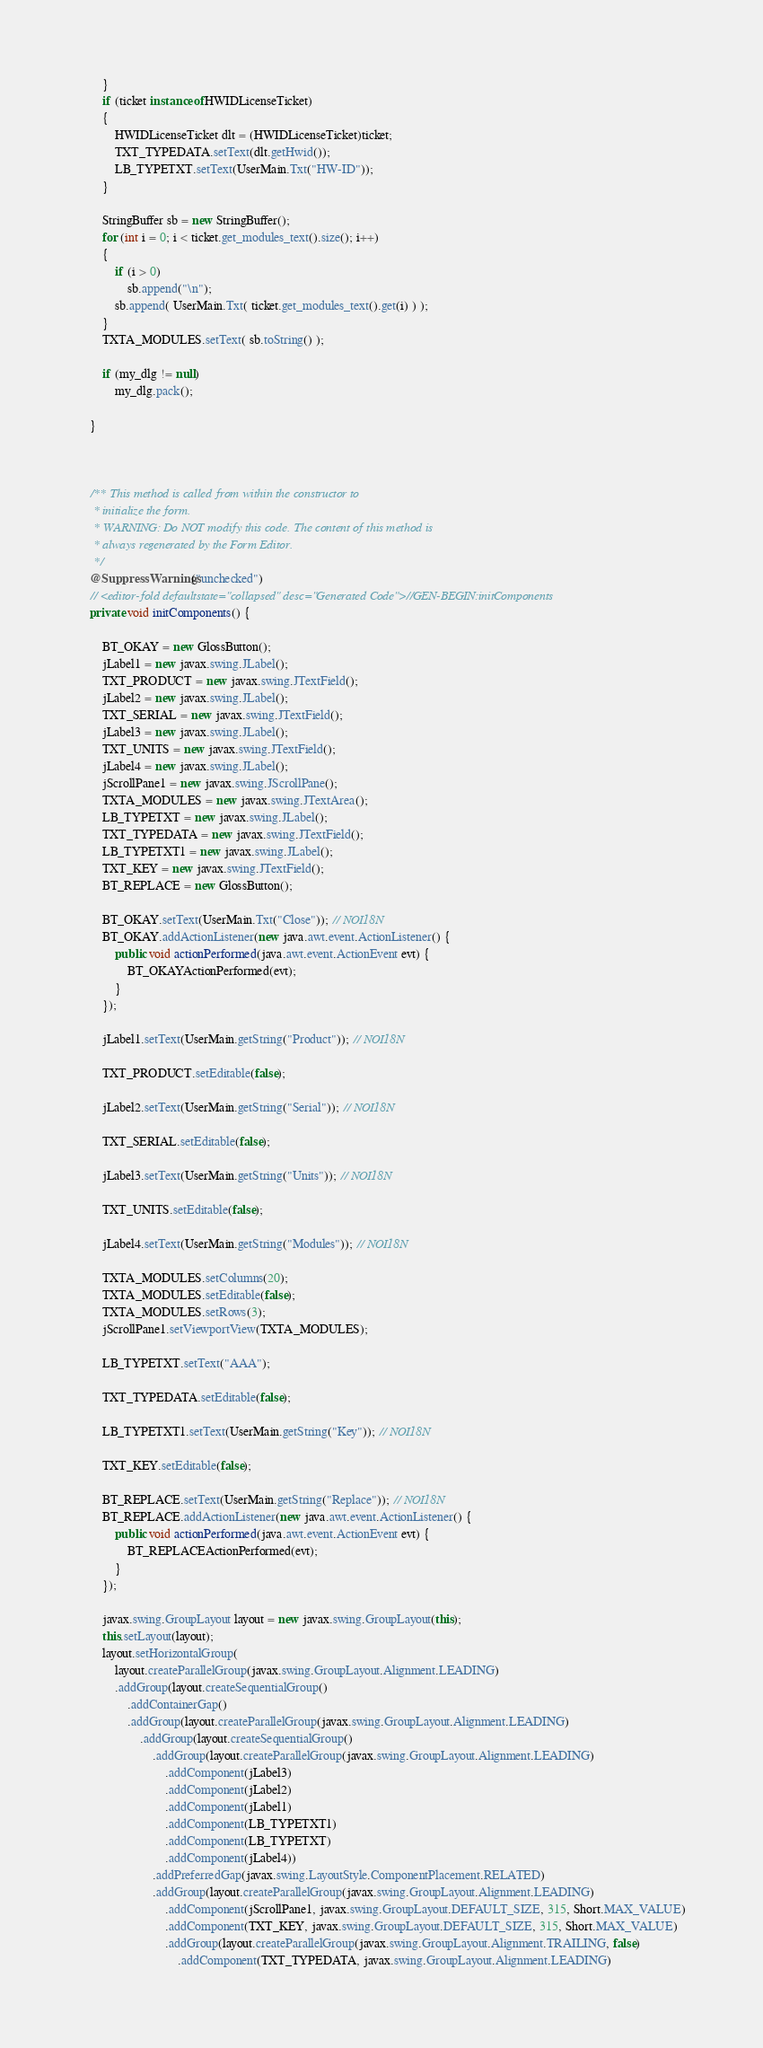Convert code to text. <code><loc_0><loc_0><loc_500><loc_500><_Java_>        }
        if (ticket instanceof HWIDLicenseTicket)
        {
            HWIDLicenseTicket dlt = (HWIDLicenseTicket)ticket;
            TXT_TYPEDATA.setText(dlt.getHwid());
            LB_TYPETXT.setText(UserMain.Txt("HW-ID"));
        }
        
        StringBuffer sb = new StringBuffer();
        for (int i = 0; i < ticket.get_modules_text().size(); i++)
        {
            if (i > 0)
                sb.append("\n");
            sb.append( UserMain.Txt( ticket.get_modules_text().get(i) ) );
        }
        TXTA_MODULES.setText( sb.toString() );

        if (my_dlg != null)
            my_dlg.pack();
        
    }



    /** This method is called from within the constructor to
     * initialize the form.
     * WARNING: Do NOT modify this code. The content of this method is
     * always regenerated by the Form Editor.
     */
    @SuppressWarnings("unchecked")
    // <editor-fold defaultstate="collapsed" desc="Generated Code">//GEN-BEGIN:initComponents
    private void initComponents() {

        BT_OKAY = new GlossButton();
        jLabel1 = new javax.swing.JLabel();
        TXT_PRODUCT = new javax.swing.JTextField();
        jLabel2 = new javax.swing.JLabel();
        TXT_SERIAL = new javax.swing.JTextField();
        jLabel3 = new javax.swing.JLabel();
        TXT_UNITS = new javax.swing.JTextField();
        jLabel4 = new javax.swing.JLabel();
        jScrollPane1 = new javax.swing.JScrollPane();
        TXTA_MODULES = new javax.swing.JTextArea();
        LB_TYPETXT = new javax.swing.JLabel();
        TXT_TYPEDATA = new javax.swing.JTextField();
        LB_TYPETXT1 = new javax.swing.JLabel();
        TXT_KEY = new javax.swing.JTextField();
        BT_REPLACE = new GlossButton();

        BT_OKAY.setText(UserMain.Txt("Close")); // NOI18N
        BT_OKAY.addActionListener(new java.awt.event.ActionListener() {
            public void actionPerformed(java.awt.event.ActionEvent evt) {
                BT_OKAYActionPerformed(evt);
            }
        });

        jLabel1.setText(UserMain.getString("Product")); // NOI18N

        TXT_PRODUCT.setEditable(false);

        jLabel2.setText(UserMain.getString("Serial")); // NOI18N

        TXT_SERIAL.setEditable(false);

        jLabel3.setText(UserMain.getString("Units")); // NOI18N

        TXT_UNITS.setEditable(false);

        jLabel4.setText(UserMain.getString("Modules")); // NOI18N

        TXTA_MODULES.setColumns(20);
        TXTA_MODULES.setEditable(false);
        TXTA_MODULES.setRows(3);
        jScrollPane1.setViewportView(TXTA_MODULES);

        LB_TYPETXT.setText("AAA");

        TXT_TYPEDATA.setEditable(false);

        LB_TYPETXT1.setText(UserMain.getString("Key")); // NOI18N

        TXT_KEY.setEditable(false);

        BT_REPLACE.setText(UserMain.getString("Replace")); // NOI18N
        BT_REPLACE.addActionListener(new java.awt.event.ActionListener() {
            public void actionPerformed(java.awt.event.ActionEvent evt) {
                BT_REPLACEActionPerformed(evt);
            }
        });

        javax.swing.GroupLayout layout = new javax.swing.GroupLayout(this);
        this.setLayout(layout);
        layout.setHorizontalGroup(
            layout.createParallelGroup(javax.swing.GroupLayout.Alignment.LEADING)
            .addGroup(layout.createSequentialGroup()
                .addContainerGap()
                .addGroup(layout.createParallelGroup(javax.swing.GroupLayout.Alignment.LEADING)
                    .addGroup(layout.createSequentialGroup()
                        .addGroup(layout.createParallelGroup(javax.swing.GroupLayout.Alignment.LEADING)
                            .addComponent(jLabel3)
                            .addComponent(jLabel2)
                            .addComponent(jLabel1)
                            .addComponent(LB_TYPETXT1)
                            .addComponent(LB_TYPETXT)
                            .addComponent(jLabel4))
                        .addPreferredGap(javax.swing.LayoutStyle.ComponentPlacement.RELATED)
                        .addGroup(layout.createParallelGroup(javax.swing.GroupLayout.Alignment.LEADING)
                            .addComponent(jScrollPane1, javax.swing.GroupLayout.DEFAULT_SIZE, 315, Short.MAX_VALUE)
                            .addComponent(TXT_KEY, javax.swing.GroupLayout.DEFAULT_SIZE, 315, Short.MAX_VALUE)
                            .addGroup(layout.createParallelGroup(javax.swing.GroupLayout.Alignment.TRAILING, false)
                                .addComponent(TXT_TYPEDATA, javax.swing.GroupLayout.Alignment.LEADING)</code> 